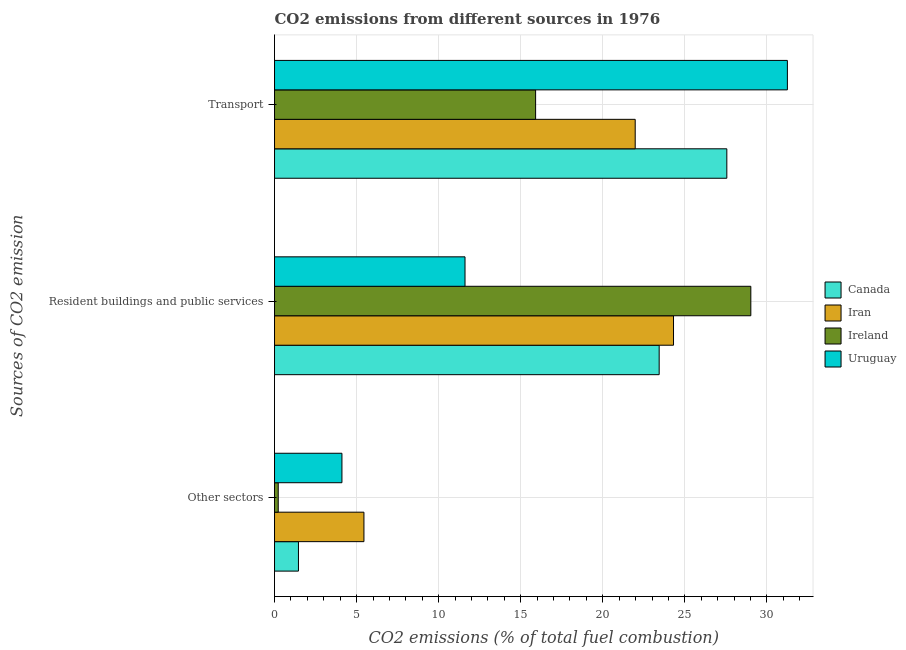How many groups of bars are there?
Your response must be concise. 3. Are the number of bars per tick equal to the number of legend labels?
Make the answer very short. Yes. Are the number of bars on each tick of the Y-axis equal?
Provide a succinct answer. Yes. How many bars are there on the 3rd tick from the top?
Provide a short and direct response. 4. How many bars are there on the 3rd tick from the bottom?
Ensure brevity in your answer.  4. What is the label of the 2nd group of bars from the top?
Offer a terse response. Resident buildings and public services. What is the percentage of co2 emissions from other sectors in Uruguay?
Ensure brevity in your answer.  4.11. Across all countries, what is the maximum percentage of co2 emissions from transport?
Provide a succinct answer. 31.25. Across all countries, what is the minimum percentage of co2 emissions from other sectors?
Ensure brevity in your answer.  0.23. In which country was the percentage of co2 emissions from transport maximum?
Your answer should be very brief. Uruguay. In which country was the percentage of co2 emissions from resident buildings and public services minimum?
Keep it short and to the point. Uruguay. What is the total percentage of co2 emissions from other sectors in the graph?
Provide a short and direct response. 11.24. What is the difference between the percentage of co2 emissions from transport in Canada and that in Ireland?
Provide a succinct answer. 11.65. What is the difference between the percentage of co2 emissions from resident buildings and public services in Uruguay and the percentage of co2 emissions from other sectors in Canada?
Your answer should be very brief. 10.15. What is the average percentage of co2 emissions from resident buildings and public services per country?
Make the answer very short. 22.09. What is the difference between the percentage of co2 emissions from resident buildings and public services and percentage of co2 emissions from transport in Ireland?
Your answer should be compact. 13.11. What is the ratio of the percentage of co2 emissions from resident buildings and public services in Ireland to that in Canada?
Make the answer very short. 1.24. Is the percentage of co2 emissions from other sectors in Ireland less than that in Iran?
Your answer should be very brief. Yes. Is the difference between the percentage of co2 emissions from transport in Canada and Iran greater than the difference between the percentage of co2 emissions from other sectors in Canada and Iran?
Provide a succinct answer. Yes. What is the difference between the highest and the second highest percentage of co2 emissions from resident buildings and public services?
Ensure brevity in your answer.  4.71. What is the difference between the highest and the lowest percentage of co2 emissions from resident buildings and public services?
Provide a short and direct response. 17.41. Is the sum of the percentage of co2 emissions from resident buildings and public services in Canada and Uruguay greater than the maximum percentage of co2 emissions from other sectors across all countries?
Offer a terse response. Yes. What does the 1st bar from the top in Resident buildings and public services represents?
Provide a succinct answer. Uruguay. What does the 2nd bar from the bottom in Resident buildings and public services represents?
Your answer should be compact. Iran. Is it the case that in every country, the sum of the percentage of co2 emissions from other sectors and percentage of co2 emissions from resident buildings and public services is greater than the percentage of co2 emissions from transport?
Your answer should be very brief. No. Are all the bars in the graph horizontal?
Give a very brief answer. Yes. How many countries are there in the graph?
Offer a very short reply. 4. Are the values on the major ticks of X-axis written in scientific E-notation?
Provide a short and direct response. No. Where does the legend appear in the graph?
Your response must be concise. Center right. What is the title of the graph?
Your response must be concise. CO2 emissions from different sources in 1976. Does "Mexico" appear as one of the legend labels in the graph?
Your answer should be compact. No. What is the label or title of the X-axis?
Your answer should be compact. CO2 emissions (% of total fuel combustion). What is the label or title of the Y-axis?
Give a very brief answer. Sources of CO2 emission. What is the CO2 emissions (% of total fuel combustion) in Canada in Other sectors?
Your answer should be compact. 1.46. What is the CO2 emissions (% of total fuel combustion) in Iran in Other sectors?
Offer a very short reply. 5.45. What is the CO2 emissions (% of total fuel combustion) in Ireland in Other sectors?
Your answer should be compact. 0.23. What is the CO2 emissions (% of total fuel combustion) of Uruguay in Other sectors?
Offer a very short reply. 4.11. What is the CO2 emissions (% of total fuel combustion) of Canada in Resident buildings and public services?
Make the answer very short. 23.44. What is the CO2 emissions (% of total fuel combustion) in Iran in Resident buildings and public services?
Offer a terse response. 24.31. What is the CO2 emissions (% of total fuel combustion) of Ireland in Resident buildings and public services?
Make the answer very short. 29.02. What is the CO2 emissions (% of total fuel combustion) in Uruguay in Resident buildings and public services?
Provide a succinct answer. 11.61. What is the CO2 emissions (% of total fuel combustion) of Canada in Transport?
Give a very brief answer. 27.56. What is the CO2 emissions (% of total fuel combustion) of Iran in Transport?
Make the answer very short. 21.98. What is the CO2 emissions (% of total fuel combustion) in Ireland in Transport?
Give a very brief answer. 15.91. What is the CO2 emissions (% of total fuel combustion) of Uruguay in Transport?
Keep it short and to the point. 31.25. Across all Sources of CO2 emission, what is the maximum CO2 emissions (% of total fuel combustion) of Canada?
Provide a succinct answer. 27.56. Across all Sources of CO2 emission, what is the maximum CO2 emissions (% of total fuel combustion) in Iran?
Your answer should be compact. 24.31. Across all Sources of CO2 emission, what is the maximum CO2 emissions (% of total fuel combustion) of Ireland?
Keep it short and to the point. 29.02. Across all Sources of CO2 emission, what is the maximum CO2 emissions (% of total fuel combustion) of Uruguay?
Offer a terse response. 31.25. Across all Sources of CO2 emission, what is the minimum CO2 emissions (% of total fuel combustion) of Canada?
Give a very brief answer. 1.46. Across all Sources of CO2 emission, what is the minimum CO2 emissions (% of total fuel combustion) of Iran?
Offer a terse response. 5.45. Across all Sources of CO2 emission, what is the minimum CO2 emissions (% of total fuel combustion) in Ireland?
Your answer should be compact. 0.23. Across all Sources of CO2 emission, what is the minimum CO2 emissions (% of total fuel combustion) in Uruguay?
Your response must be concise. 4.11. What is the total CO2 emissions (% of total fuel combustion) of Canada in the graph?
Offer a very short reply. 52.45. What is the total CO2 emissions (% of total fuel combustion) in Iran in the graph?
Give a very brief answer. 51.74. What is the total CO2 emissions (% of total fuel combustion) of Ireland in the graph?
Give a very brief answer. 45.16. What is the total CO2 emissions (% of total fuel combustion) in Uruguay in the graph?
Keep it short and to the point. 46.96. What is the difference between the CO2 emissions (% of total fuel combustion) of Canada in Other sectors and that in Resident buildings and public services?
Give a very brief answer. -21.98. What is the difference between the CO2 emissions (% of total fuel combustion) of Iran in Other sectors and that in Resident buildings and public services?
Make the answer very short. -18.86. What is the difference between the CO2 emissions (% of total fuel combustion) of Ireland in Other sectors and that in Resident buildings and public services?
Offer a terse response. -28.8. What is the difference between the CO2 emissions (% of total fuel combustion) of Canada in Other sectors and that in Transport?
Ensure brevity in your answer.  -26.1. What is the difference between the CO2 emissions (% of total fuel combustion) of Iran in Other sectors and that in Transport?
Offer a terse response. -16.53. What is the difference between the CO2 emissions (% of total fuel combustion) of Ireland in Other sectors and that in Transport?
Your answer should be very brief. -15.68. What is the difference between the CO2 emissions (% of total fuel combustion) of Uruguay in Other sectors and that in Transport?
Provide a succinct answer. -27.14. What is the difference between the CO2 emissions (% of total fuel combustion) of Canada in Resident buildings and public services and that in Transport?
Ensure brevity in your answer.  -4.12. What is the difference between the CO2 emissions (% of total fuel combustion) of Iran in Resident buildings and public services and that in Transport?
Keep it short and to the point. 2.33. What is the difference between the CO2 emissions (% of total fuel combustion) of Ireland in Resident buildings and public services and that in Transport?
Make the answer very short. 13.11. What is the difference between the CO2 emissions (% of total fuel combustion) in Uruguay in Resident buildings and public services and that in Transport?
Keep it short and to the point. -19.64. What is the difference between the CO2 emissions (% of total fuel combustion) of Canada in Other sectors and the CO2 emissions (% of total fuel combustion) of Iran in Resident buildings and public services?
Make the answer very short. -22.85. What is the difference between the CO2 emissions (% of total fuel combustion) of Canada in Other sectors and the CO2 emissions (% of total fuel combustion) of Ireland in Resident buildings and public services?
Offer a terse response. -27.56. What is the difference between the CO2 emissions (% of total fuel combustion) in Canada in Other sectors and the CO2 emissions (% of total fuel combustion) in Uruguay in Resident buildings and public services?
Ensure brevity in your answer.  -10.15. What is the difference between the CO2 emissions (% of total fuel combustion) of Iran in Other sectors and the CO2 emissions (% of total fuel combustion) of Ireland in Resident buildings and public services?
Ensure brevity in your answer.  -23.57. What is the difference between the CO2 emissions (% of total fuel combustion) of Iran in Other sectors and the CO2 emissions (% of total fuel combustion) of Uruguay in Resident buildings and public services?
Your answer should be very brief. -6.16. What is the difference between the CO2 emissions (% of total fuel combustion) of Ireland in Other sectors and the CO2 emissions (% of total fuel combustion) of Uruguay in Resident buildings and public services?
Your response must be concise. -11.38. What is the difference between the CO2 emissions (% of total fuel combustion) in Canada in Other sectors and the CO2 emissions (% of total fuel combustion) in Iran in Transport?
Provide a succinct answer. -20.52. What is the difference between the CO2 emissions (% of total fuel combustion) of Canada in Other sectors and the CO2 emissions (% of total fuel combustion) of Ireland in Transport?
Make the answer very short. -14.45. What is the difference between the CO2 emissions (% of total fuel combustion) of Canada in Other sectors and the CO2 emissions (% of total fuel combustion) of Uruguay in Transport?
Give a very brief answer. -29.79. What is the difference between the CO2 emissions (% of total fuel combustion) in Iran in Other sectors and the CO2 emissions (% of total fuel combustion) in Ireland in Transport?
Provide a short and direct response. -10.46. What is the difference between the CO2 emissions (% of total fuel combustion) in Iran in Other sectors and the CO2 emissions (% of total fuel combustion) in Uruguay in Transport?
Offer a terse response. -25.8. What is the difference between the CO2 emissions (% of total fuel combustion) of Ireland in Other sectors and the CO2 emissions (% of total fuel combustion) of Uruguay in Transport?
Make the answer very short. -31.02. What is the difference between the CO2 emissions (% of total fuel combustion) in Canada in Resident buildings and public services and the CO2 emissions (% of total fuel combustion) in Iran in Transport?
Make the answer very short. 1.46. What is the difference between the CO2 emissions (% of total fuel combustion) in Canada in Resident buildings and public services and the CO2 emissions (% of total fuel combustion) in Ireland in Transport?
Offer a very short reply. 7.53. What is the difference between the CO2 emissions (% of total fuel combustion) in Canada in Resident buildings and public services and the CO2 emissions (% of total fuel combustion) in Uruguay in Transport?
Ensure brevity in your answer.  -7.81. What is the difference between the CO2 emissions (% of total fuel combustion) of Iran in Resident buildings and public services and the CO2 emissions (% of total fuel combustion) of Ireland in Transport?
Keep it short and to the point. 8.4. What is the difference between the CO2 emissions (% of total fuel combustion) in Iran in Resident buildings and public services and the CO2 emissions (% of total fuel combustion) in Uruguay in Transport?
Provide a short and direct response. -6.94. What is the difference between the CO2 emissions (% of total fuel combustion) in Ireland in Resident buildings and public services and the CO2 emissions (% of total fuel combustion) in Uruguay in Transport?
Provide a succinct answer. -2.23. What is the average CO2 emissions (% of total fuel combustion) of Canada per Sources of CO2 emission?
Provide a succinct answer. 17.48. What is the average CO2 emissions (% of total fuel combustion) in Iran per Sources of CO2 emission?
Provide a short and direct response. 17.25. What is the average CO2 emissions (% of total fuel combustion) in Ireland per Sources of CO2 emission?
Ensure brevity in your answer.  15.05. What is the average CO2 emissions (% of total fuel combustion) in Uruguay per Sources of CO2 emission?
Make the answer very short. 15.65. What is the difference between the CO2 emissions (% of total fuel combustion) of Canada and CO2 emissions (% of total fuel combustion) of Iran in Other sectors?
Your answer should be compact. -3.99. What is the difference between the CO2 emissions (% of total fuel combustion) of Canada and CO2 emissions (% of total fuel combustion) of Ireland in Other sectors?
Provide a short and direct response. 1.23. What is the difference between the CO2 emissions (% of total fuel combustion) of Canada and CO2 emissions (% of total fuel combustion) of Uruguay in Other sectors?
Keep it short and to the point. -2.65. What is the difference between the CO2 emissions (% of total fuel combustion) of Iran and CO2 emissions (% of total fuel combustion) of Ireland in Other sectors?
Keep it short and to the point. 5.22. What is the difference between the CO2 emissions (% of total fuel combustion) in Iran and CO2 emissions (% of total fuel combustion) in Uruguay in Other sectors?
Your answer should be compact. 1.34. What is the difference between the CO2 emissions (% of total fuel combustion) of Ireland and CO2 emissions (% of total fuel combustion) of Uruguay in Other sectors?
Keep it short and to the point. -3.88. What is the difference between the CO2 emissions (% of total fuel combustion) of Canada and CO2 emissions (% of total fuel combustion) of Iran in Resident buildings and public services?
Ensure brevity in your answer.  -0.87. What is the difference between the CO2 emissions (% of total fuel combustion) of Canada and CO2 emissions (% of total fuel combustion) of Ireland in Resident buildings and public services?
Ensure brevity in your answer.  -5.58. What is the difference between the CO2 emissions (% of total fuel combustion) in Canada and CO2 emissions (% of total fuel combustion) in Uruguay in Resident buildings and public services?
Keep it short and to the point. 11.83. What is the difference between the CO2 emissions (% of total fuel combustion) of Iran and CO2 emissions (% of total fuel combustion) of Ireland in Resident buildings and public services?
Give a very brief answer. -4.71. What is the difference between the CO2 emissions (% of total fuel combustion) of Iran and CO2 emissions (% of total fuel combustion) of Uruguay in Resident buildings and public services?
Ensure brevity in your answer.  12.7. What is the difference between the CO2 emissions (% of total fuel combustion) of Ireland and CO2 emissions (% of total fuel combustion) of Uruguay in Resident buildings and public services?
Offer a terse response. 17.41. What is the difference between the CO2 emissions (% of total fuel combustion) of Canada and CO2 emissions (% of total fuel combustion) of Iran in Transport?
Provide a short and direct response. 5.58. What is the difference between the CO2 emissions (% of total fuel combustion) in Canada and CO2 emissions (% of total fuel combustion) in Ireland in Transport?
Provide a short and direct response. 11.65. What is the difference between the CO2 emissions (% of total fuel combustion) of Canada and CO2 emissions (% of total fuel combustion) of Uruguay in Transport?
Offer a very short reply. -3.69. What is the difference between the CO2 emissions (% of total fuel combustion) of Iran and CO2 emissions (% of total fuel combustion) of Ireland in Transport?
Your answer should be very brief. 6.07. What is the difference between the CO2 emissions (% of total fuel combustion) in Iran and CO2 emissions (% of total fuel combustion) in Uruguay in Transport?
Your answer should be compact. -9.27. What is the difference between the CO2 emissions (% of total fuel combustion) in Ireland and CO2 emissions (% of total fuel combustion) in Uruguay in Transport?
Provide a succinct answer. -15.34. What is the ratio of the CO2 emissions (% of total fuel combustion) in Canada in Other sectors to that in Resident buildings and public services?
Provide a short and direct response. 0.06. What is the ratio of the CO2 emissions (% of total fuel combustion) of Iran in Other sectors to that in Resident buildings and public services?
Ensure brevity in your answer.  0.22. What is the ratio of the CO2 emissions (% of total fuel combustion) in Ireland in Other sectors to that in Resident buildings and public services?
Provide a short and direct response. 0.01. What is the ratio of the CO2 emissions (% of total fuel combustion) in Uruguay in Other sectors to that in Resident buildings and public services?
Provide a short and direct response. 0.35. What is the ratio of the CO2 emissions (% of total fuel combustion) of Canada in Other sectors to that in Transport?
Your answer should be compact. 0.05. What is the ratio of the CO2 emissions (% of total fuel combustion) of Iran in Other sectors to that in Transport?
Offer a terse response. 0.25. What is the ratio of the CO2 emissions (% of total fuel combustion) in Ireland in Other sectors to that in Transport?
Give a very brief answer. 0.01. What is the ratio of the CO2 emissions (% of total fuel combustion) in Uruguay in Other sectors to that in Transport?
Ensure brevity in your answer.  0.13. What is the ratio of the CO2 emissions (% of total fuel combustion) of Canada in Resident buildings and public services to that in Transport?
Your response must be concise. 0.85. What is the ratio of the CO2 emissions (% of total fuel combustion) in Iran in Resident buildings and public services to that in Transport?
Offer a very short reply. 1.11. What is the ratio of the CO2 emissions (% of total fuel combustion) of Ireland in Resident buildings and public services to that in Transport?
Your answer should be very brief. 1.82. What is the ratio of the CO2 emissions (% of total fuel combustion) of Uruguay in Resident buildings and public services to that in Transport?
Give a very brief answer. 0.37. What is the difference between the highest and the second highest CO2 emissions (% of total fuel combustion) in Canada?
Offer a terse response. 4.12. What is the difference between the highest and the second highest CO2 emissions (% of total fuel combustion) in Iran?
Offer a terse response. 2.33. What is the difference between the highest and the second highest CO2 emissions (% of total fuel combustion) in Ireland?
Keep it short and to the point. 13.11. What is the difference between the highest and the second highest CO2 emissions (% of total fuel combustion) in Uruguay?
Your response must be concise. 19.64. What is the difference between the highest and the lowest CO2 emissions (% of total fuel combustion) in Canada?
Keep it short and to the point. 26.1. What is the difference between the highest and the lowest CO2 emissions (% of total fuel combustion) in Iran?
Your response must be concise. 18.86. What is the difference between the highest and the lowest CO2 emissions (% of total fuel combustion) in Ireland?
Your response must be concise. 28.8. What is the difference between the highest and the lowest CO2 emissions (% of total fuel combustion) of Uruguay?
Make the answer very short. 27.14. 